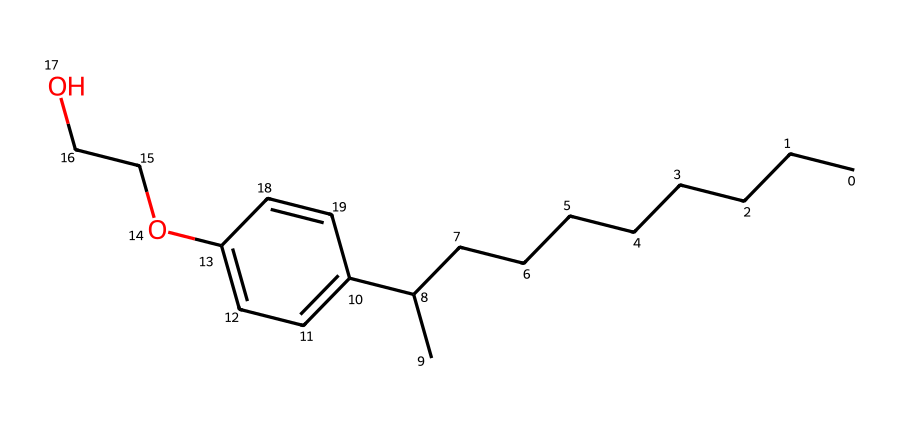What is the total number of carbon atoms in this molecule? By analyzing the SMILES representation, we can identify the carbon atoms in the linear alkyl chain (nonyl part) as well as those in the aromatic ring (c1ccc). The nonyl group contributes 9 carbon atoms, and the aromatic ring contributes 6 more, totaling 15 carbon atoms.
Answer: 15 How many oxygen atoms are present in this chemical structure? Observing the SMILES, we note there are two "O" characters (O) corresponding to the ethoxy groups (OCC), indicating the presence of two oxygen atoms in the structure.
Answer: 2 What type of functional groups are present in this compound? The presence of the "OCCO" segment indicates that there are ether functional groups (specifically ethoxy groups), and the hydroxyl group (-OH) attached to the aromatic ring signifies that there is also a phenolic group.
Answer: ether, phenol What is the significance of the long alkyl chain in detergents? The long alkyl chain (nonyl group) provides hydrophobic properties, making the detergent effective in breaking down grease and oils. This hydrophobic tail aids in solubilizing non-polar substances, enhancing cleaning effectiveness.
Answer: hydrophobic Which part of the molecule contributes to its detergent properties? The nonyl group provides the hydrophobic character, while the ethoxy (hydrophilic) segment allows interaction with water, giving the compound the ability to function as a detergent by emulsifying oils in water.
Answer: nonyl group and ethoxy segments 